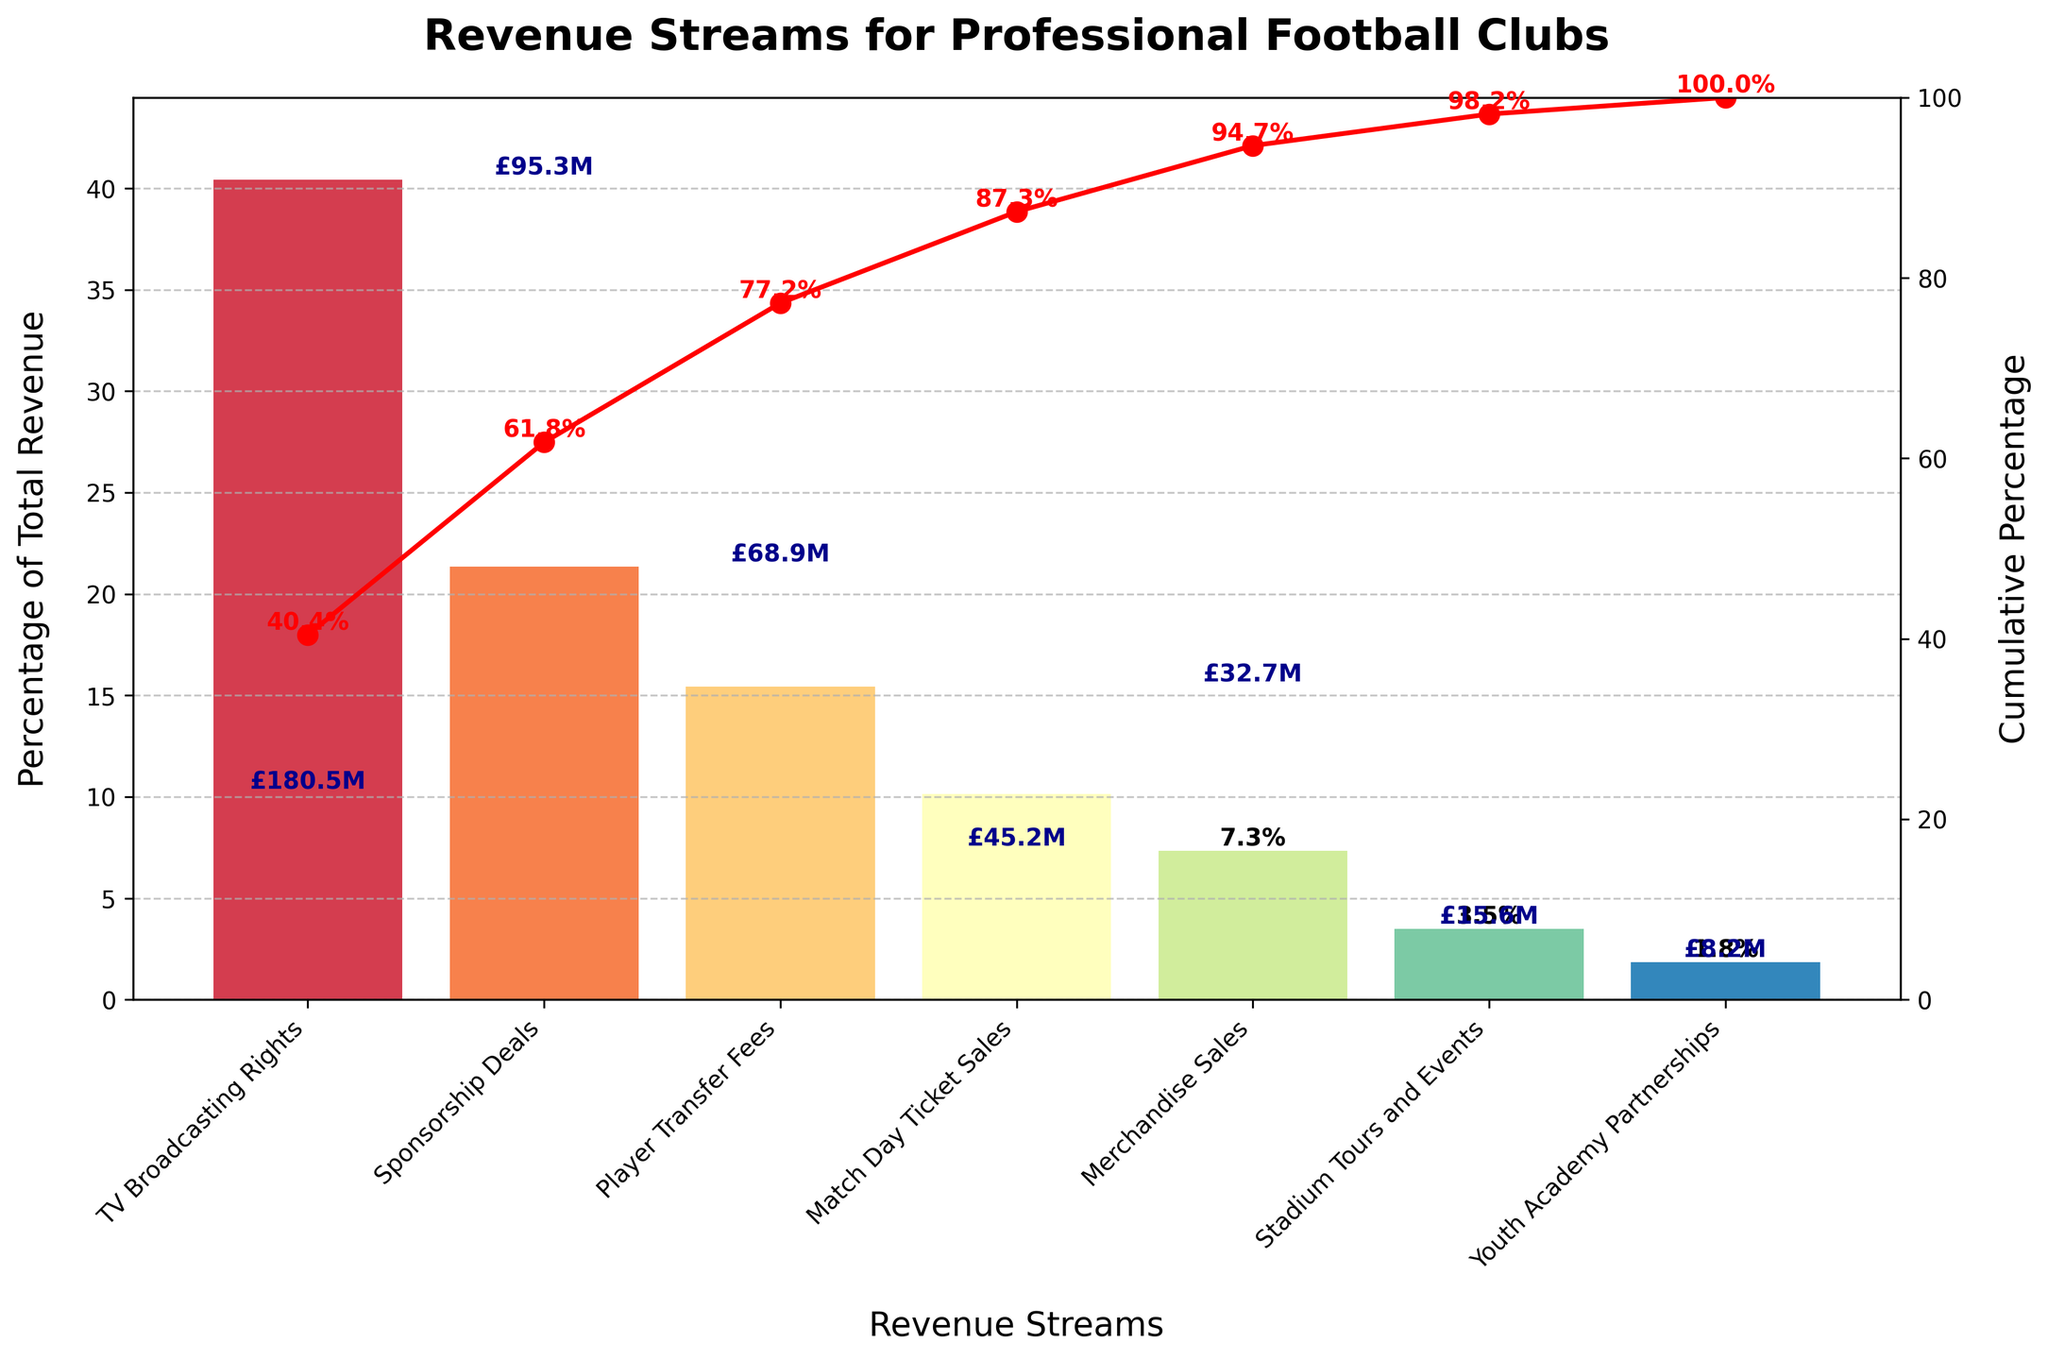What is the title of the chart? The title of the chart is typically located at the top of the figure and provides a summary of what the chart is about. In this case, it clearly states, "Revenue Streams for Professional Football Clubs".
Answer: Revenue Streams for Professional Football Clubs Which revenue stream has the highest percentage of total revenue? The highest percentage bar is the largest one in the chart and usually located at the top as the data is sorted in descending order. The label associated with this bar represents the revenue stream.
Answer: TV Broadcasting Rights What is the total percentage represented by the top three revenue streams combined? To find the combined percentage, sum the individual percentages of the top three revenue streams. Assuming the chart shows percentages for TV Broadcasting Rights, Sponsorship Deals, and Match Day Ticket Sales.
Answer: 77.1% Which revenue stream accounts for the smallest percentage of total revenue? The shortest bar in the chart, which is associated with the lowest percentage, represents the smallest revenue stream.
Answer: Youth Academy Partnerships What cumulative percentage of total revenue is reached after including the top four revenue streams? The chart shows a cumulative line that adds up the percentages sequentially. By noting the cumulative percentage just after the fourth revenue stream, you can determine the answer.
Answer: 84.5% By how much do TV Broadcasting Rights exceed Player Transfer Fees in terms of percentage of total revenue? Comparison questions require finding the difference between the two specified values. For this, subtract the percentage of Player Transfer Fees from the percentage of TV Broadcasting Rights.
Answer: 54.3% What percentage of total revenue comes from merchandise sales? Locate the bar labeled "Merchandise Sales" and read the percentage value displayed on or near the bar.
Answer: 6.6% If we combine the percentage from Match Day Ticket Sales with Stadium Tours and Events, what is the total percentage? Add the percentage values for Match Day Ticket Sales and Stadium Tours and Events as shown in their respective bars.
Answer: 10.5% How does the contribution of Sponsorship Deals compare to that of Player Transfer Fees? A comparison requires examining the relative sizes of the bars or the percentages directly indicated on them. Sponsorship Deals have a visibly larger portion than Player Transfer Fees.
Answer: Sponsorship Deals are higher What percentage does the cumulative line reach just after Merchandise Sales? The cumulative line shows the accumulated percentage up to each revenue stream. Find the value indicated at the point just after Merchandise Sales.
Answer: 98.2% 